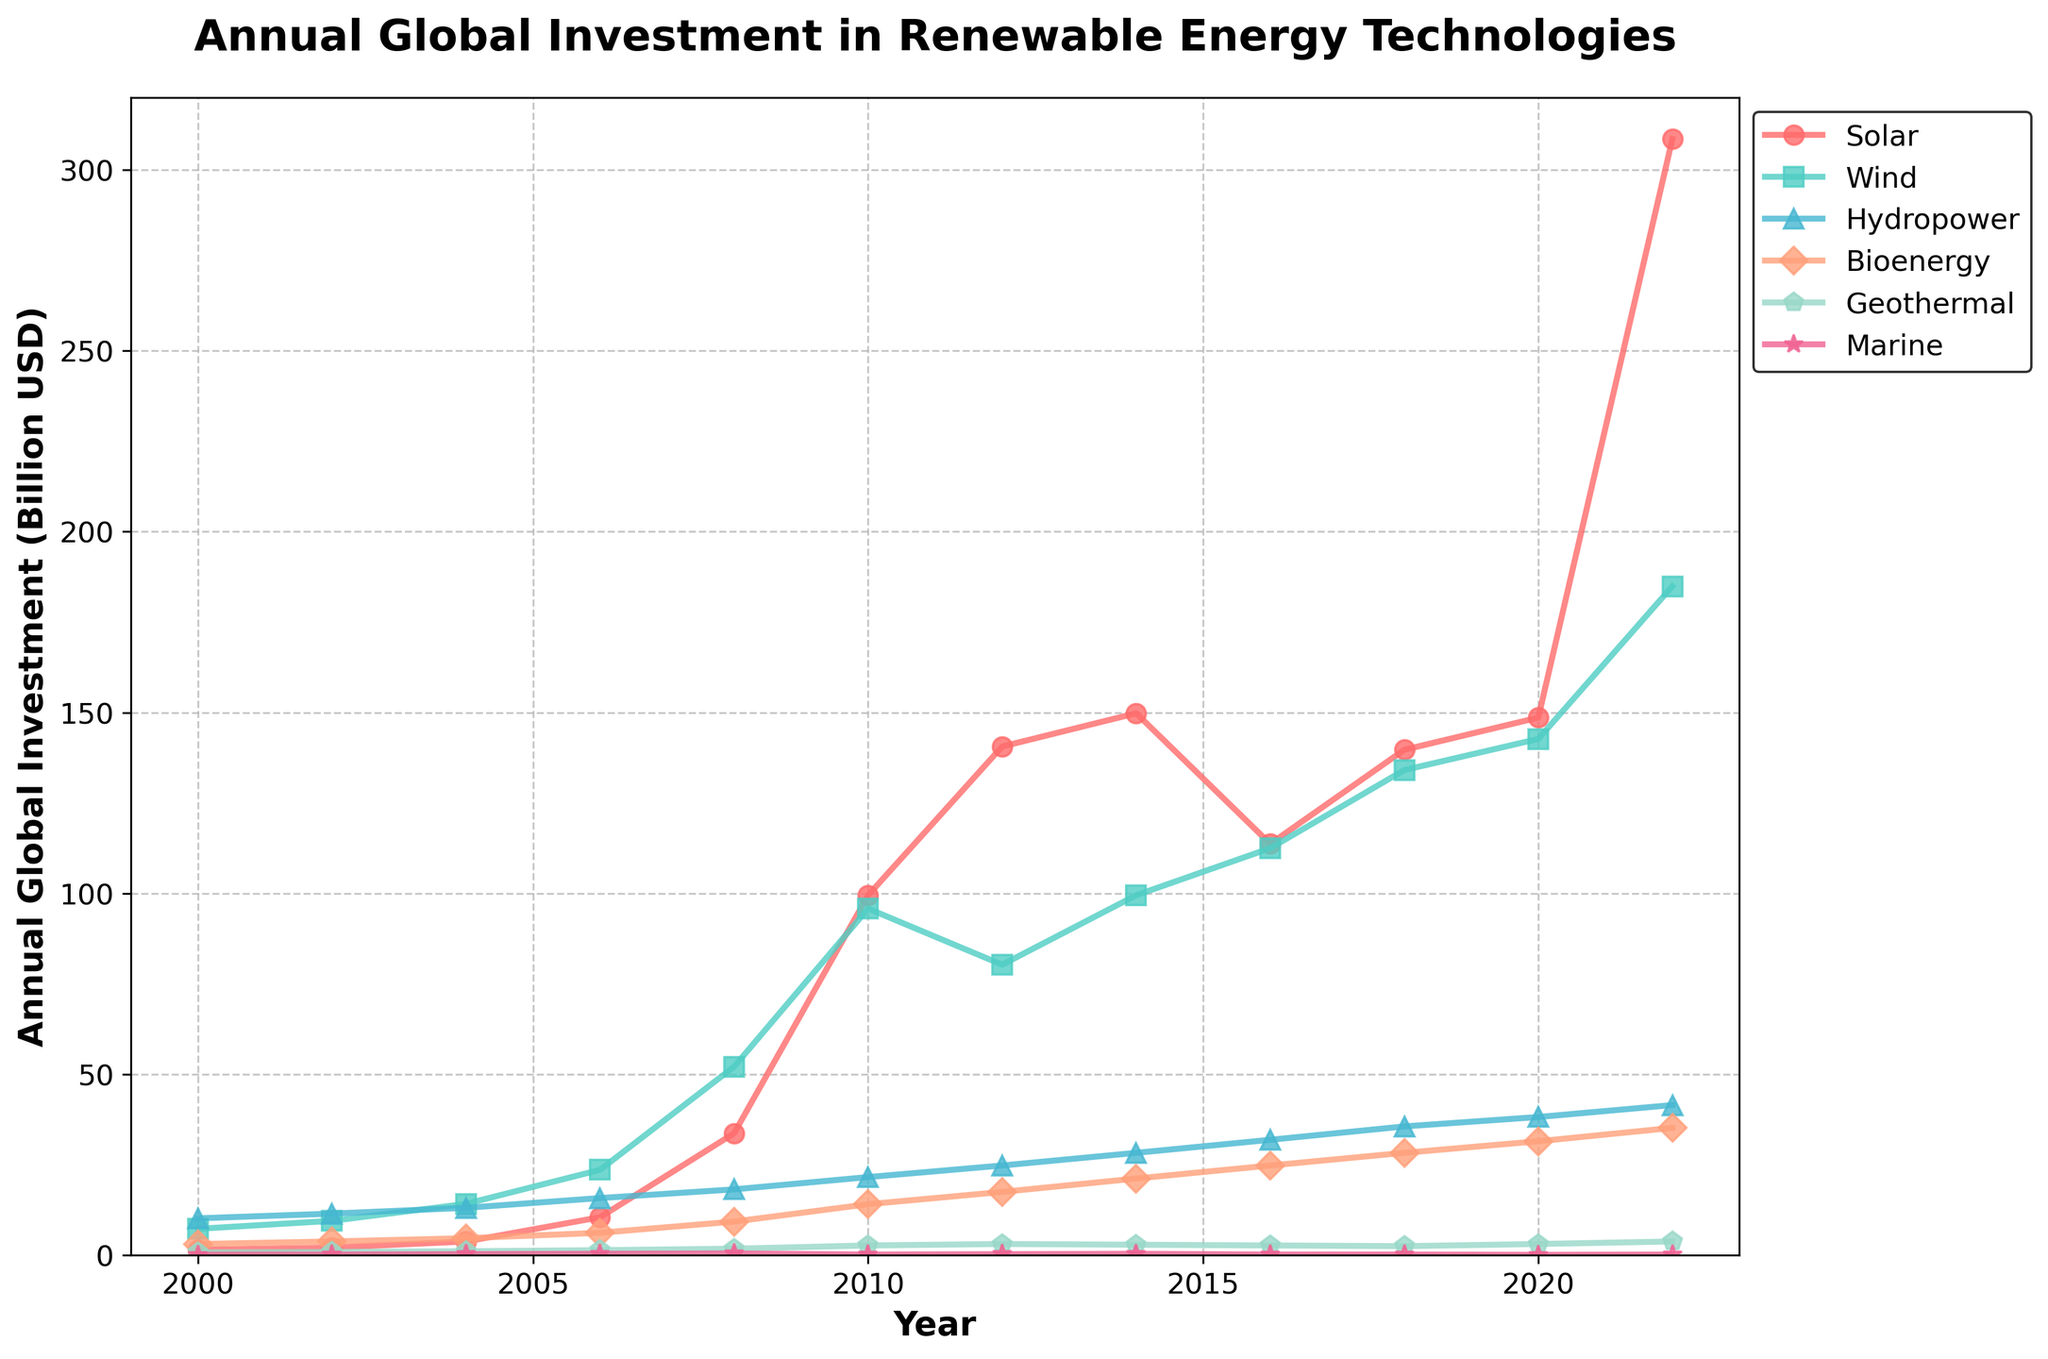What type of renewable energy saw the highest investment increase between 2000 and 2022? First, observe the investment levels in 2000 and 2022 for each renewable energy type. The increase for Solar is 308.5 - 1.5 = 307 billion USD, which is the highest increase compared to Wind (184.9 - 7.3 = 177.6 billion USD), Hydropower (41.5 - 10.2 = 31.3 billion USD), Bioenergy (35.2 - 3.1 = 32.1 billion USD), Geothermal (3.8 - 0.8 = 3 billion USD), and Marine (0.2 - 0.1 = 0.1 billion USD).
Answer: Solar Between which two years did Wind energy see the largest increase in investment? Look at the changes in investment in Wind energy between consecutive years. The largest increase is between 2018 (134.1) and 2020 (142.7), which is an increase of 8.6 billion USD.
Answer: 2018 and 2020 What was the total global investment in renewable energy technologies in the year 2010? Add the investments for all technologies in 2010: Solar (99.5) + Wind (95.8) + Hydropower (21.6) + Bioenergy (14.1) + Geothermal (2.7) + Marine (0.2) = 233.9 billion USD.
Answer: 233.9 billion USD Which renewable energy type had the smallest growth in investment from 2000 to 2022? Calculate the differences in investments from 2000 to 2022 for each energy type. Solar: 308.5 - 1.5, Wind: 184.9 - 7.3, Hydropower: 41.5 - 10.2, Bioenergy: 35.2 - 3.1, Geothermal: 3.8 - 0.8, Marine: 0.2 - 0.1. The smallest growth is in Marine energy with only an increase of 0.1 billion USD.
Answer: Marine Between 2006 and 2022, which renewable energy type had the highest average annual investment? Calculate the average annual investment for each renewable energy type between 2006 and 2022 by summing the values for these years and dividing by the number of years (16 years). Solar: (10.5 + 33.7 + 99.5 + 140.6 + 149.8 + 113.7 + 139.7 + 148.6 + 308.5) / 9 = 126.49 billion USD (approx), Wind: (23.6 + 52.1 + 95.8 + 80.3 + 99.5 + 112.5 + 134.1 + 142.7 + 184.9) / 9 = 102.83 billion USD (approx). The highest average is for Solar energy.
Answer: Solar During which decade did investment in Bioenergy show the most significant change? Compare the increments in Bioenergy investments between 2000-2010 and 2010-2020. From 2000 to 2010, the investment increased by (14.1 - 3.1) = 11 billion USD. From 2010 to 2020, it increased by (31.5 - 14.1) = 17.4 billion USD. The most significant change occurred between 2010 and 2020.
Answer: 2010-2020 Which year showed the quickest increase in Solar energy investment? By examining the plot and the data, the year with the quickest increase can be identified - from 2008 to 2010. The increase is (99.5 - 33.7) = 65.8 billion USD.
Answer: 2010 How did the investments in Geothermal energy trend over the years depicted in the plot? The investments in Geothermal energy show a consistent but modest increase from 0.8 billion USD in 2000 to 3.8 billion USD in 2022.
Answer: Increasing What is the combined investment in Marine energy from 2000 to 2022? Add the annual investments in Marine energy for all the given years (0.1 + 0.2 + 0.3 + 0.4 + 0.5 + 0.2 + 0.3 + 0.4 + 0.2 + 0.2 + 0.1 + 0.2) = 3.1 billion USD.
Answer: 3.1 billion USD 